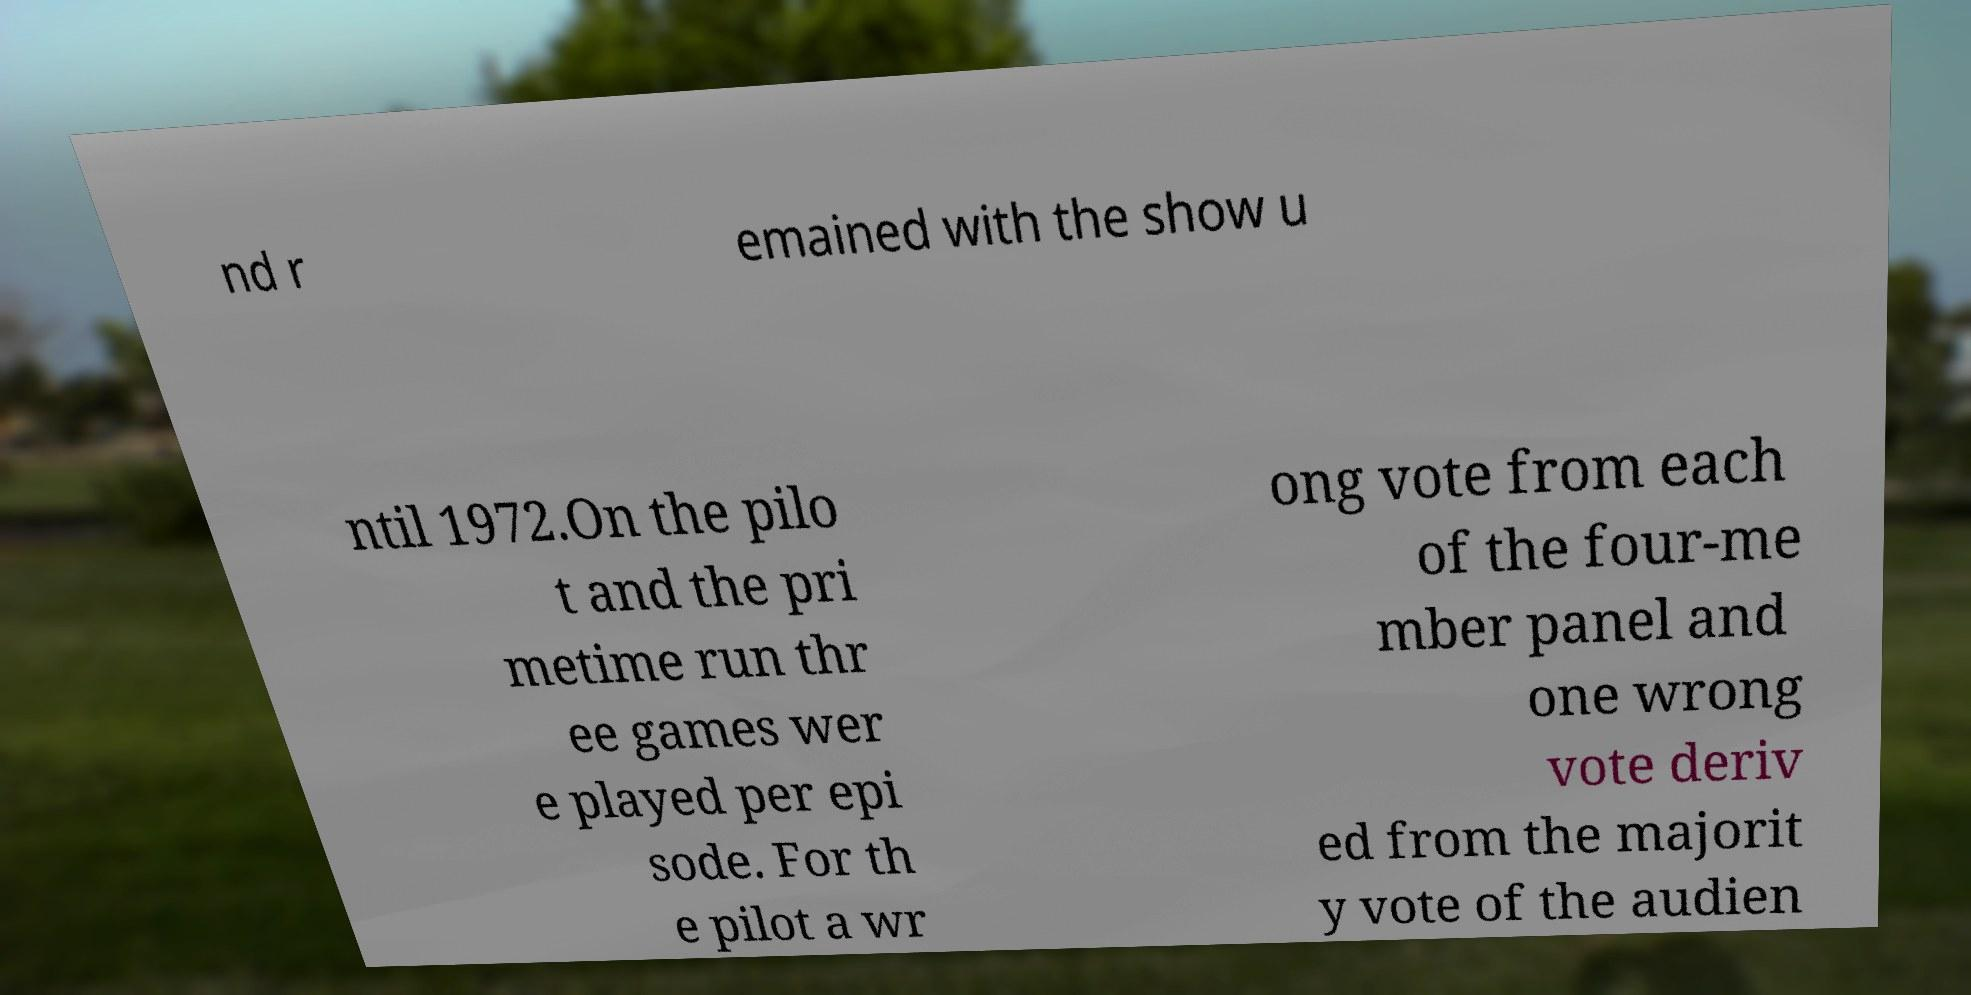Can you accurately transcribe the text from the provided image for me? nd r emained with the show u ntil 1972.On the pilo t and the pri metime run thr ee games wer e played per epi sode. For th e pilot a wr ong vote from each of the four-me mber panel and one wrong vote deriv ed from the majorit y vote of the audien 